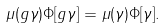<formula> <loc_0><loc_0><loc_500><loc_500>\mu ( g \gamma ) \Phi [ g \gamma ] = \mu ( \gamma ) \Phi [ \gamma ] .</formula> 